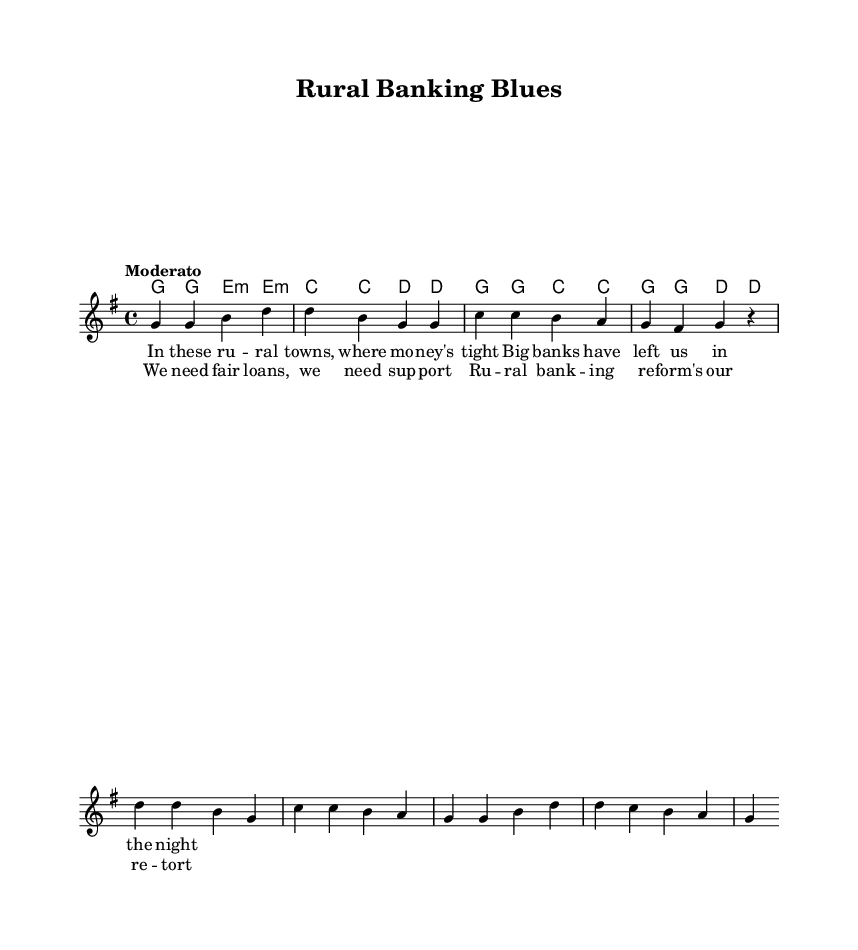What is the key signature of this music? The key signature is indicated at the beginning of the score. The presence of one sharp (F#) means it is in G major.
Answer: G major What is the time signature of this music? The time signature is found at the beginning of the piece, showing how many beats are in each measure. The 4/4 time signature signifies four beats per measure.
Answer: 4/4 What is the tempo marking of this music? The tempo marking is usually found at the beginning of the score, indicating the speed of the performance. The term "Moderato" suggests a moderate speed.
Answer: Moderato How many verses are in the melody? By examining the structure of the sheet music, it is evident that only one set of five lyric lines is provided for the verse, indicating only one verse.
Answer: One What repetitive structure does the chorus follow? The chorus lyrics appear immediately after the first verse, indicating a typical folk song structure where the chorus is repeated after each verse. The patterned lyrics in the chorus show a clear rhythmic repetition.
Answer: A repetitive pattern What thematic issue do the lyrics address? The content of the lyrics directly discusses challenges related to banking in rural areas focusing on the need for fair loans and banking reform, typical of folk protest songs which highlight social issues.
Answer: Rural banking challenges What chord progression is used in the chorus? The chord progression in the chorus can be identified by examining the harmonic clues associated with the lyrics. The sequence of chords shows a shift from G to C and back to G, which is a common progression in folk music.
Answer: G to C to G 